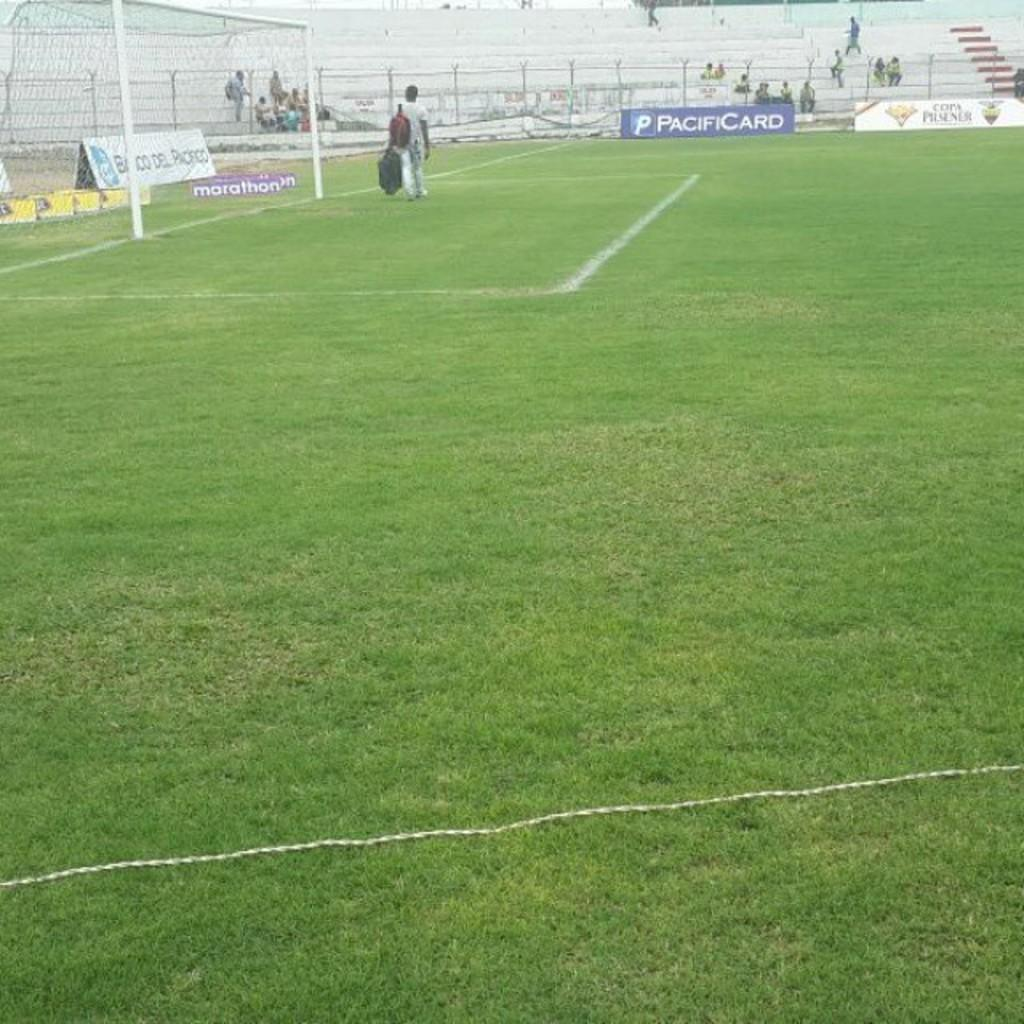Provide a one-sentence caption for the provided image. An ad for PacifiCard is at the edge of the soccer field in front of some nearly-empty bleachers. 